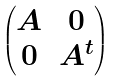<formula> <loc_0><loc_0><loc_500><loc_500>\begin{pmatrix} A & 0 \\ 0 & A ^ { t } \end{pmatrix}</formula> 